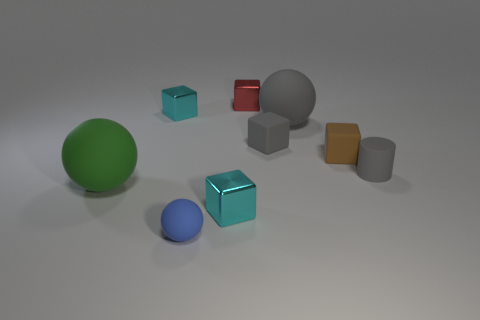Subtract all small brown cubes. How many cubes are left? 4 Subtract all brown cubes. How many cubes are left? 4 Subtract all green cubes. Subtract all yellow cylinders. How many cubes are left? 5 Add 1 spheres. How many objects exist? 10 Subtract all cubes. How many objects are left? 4 Add 4 cyan objects. How many cyan objects exist? 6 Subtract 0 purple blocks. How many objects are left? 9 Subtract all brown cubes. Subtract all tiny blue balls. How many objects are left? 7 Add 4 large spheres. How many large spheres are left? 6 